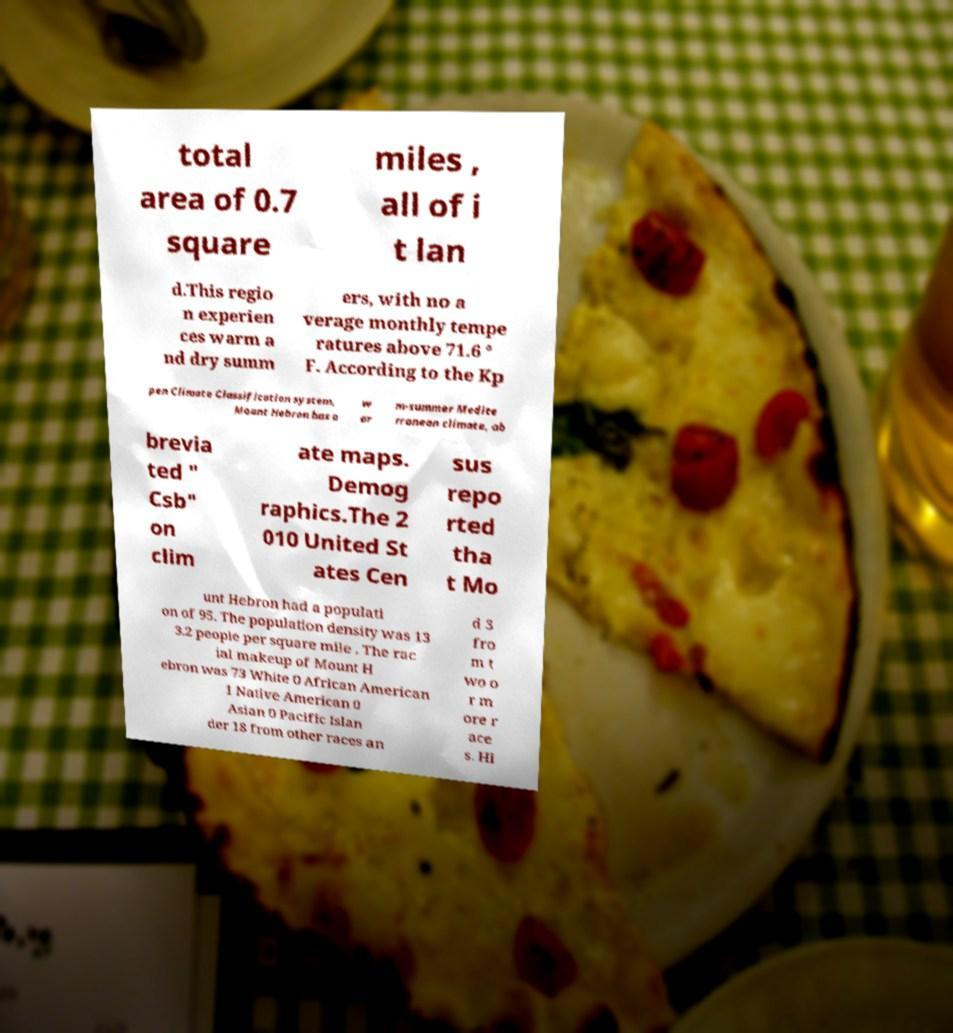Could you assist in decoding the text presented in this image and type it out clearly? total area of 0.7 square miles , all of i t lan d.This regio n experien ces warm a nd dry summ ers, with no a verage monthly tempe ratures above 71.6 ° F. According to the Kp pen Climate Classification system, Mount Hebron has a w ar m-summer Medite rranean climate, ab brevia ted " Csb" on clim ate maps. Demog raphics.The 2 010 United St ates Cen sus repo rted tha t Mo unt Hebron had a populati on of 95. The population density was 13 3.2 people per square mile . The rac ial makeup of Mount H ebron was 73 White 0 African American 1 Native American 0 Asian 0 Pacific Islan der 18 from other races an d 3 fro m t wo o r m ore r ace s. Hi 